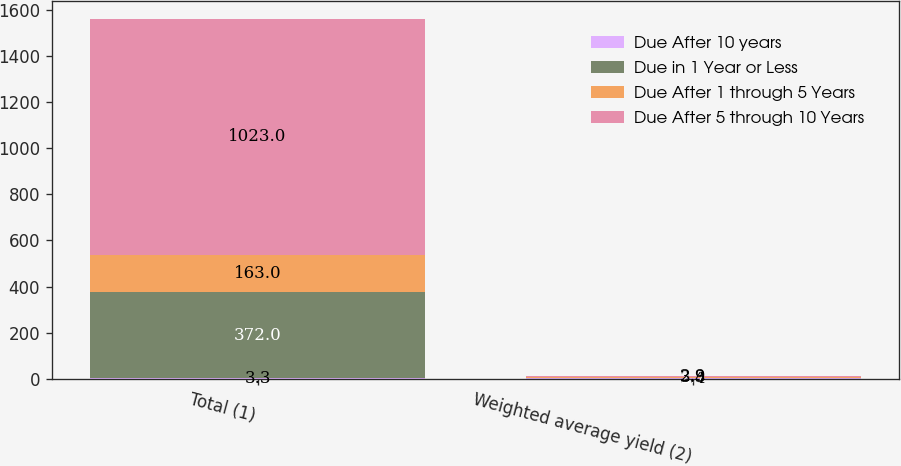<chart> <loc_0><loc_0><loc_500><loc_500><stacked_bar_chart><ecel><fcel>Total (1)<fcel>Weighted average yield (2)<nl><fcel>Due After 10 years<fcel>3.3<fcel>2.4<nl><fcel>Due in 1 Year or Less<fcel>372<fcel>2.7<nl><fcel>Due After 1 through 5 Years<fcel>163<fcel>3.3<nl><fcel>Due After 5 through 10 Years<fcel>1023<fcel>2.9<nl></chart> 